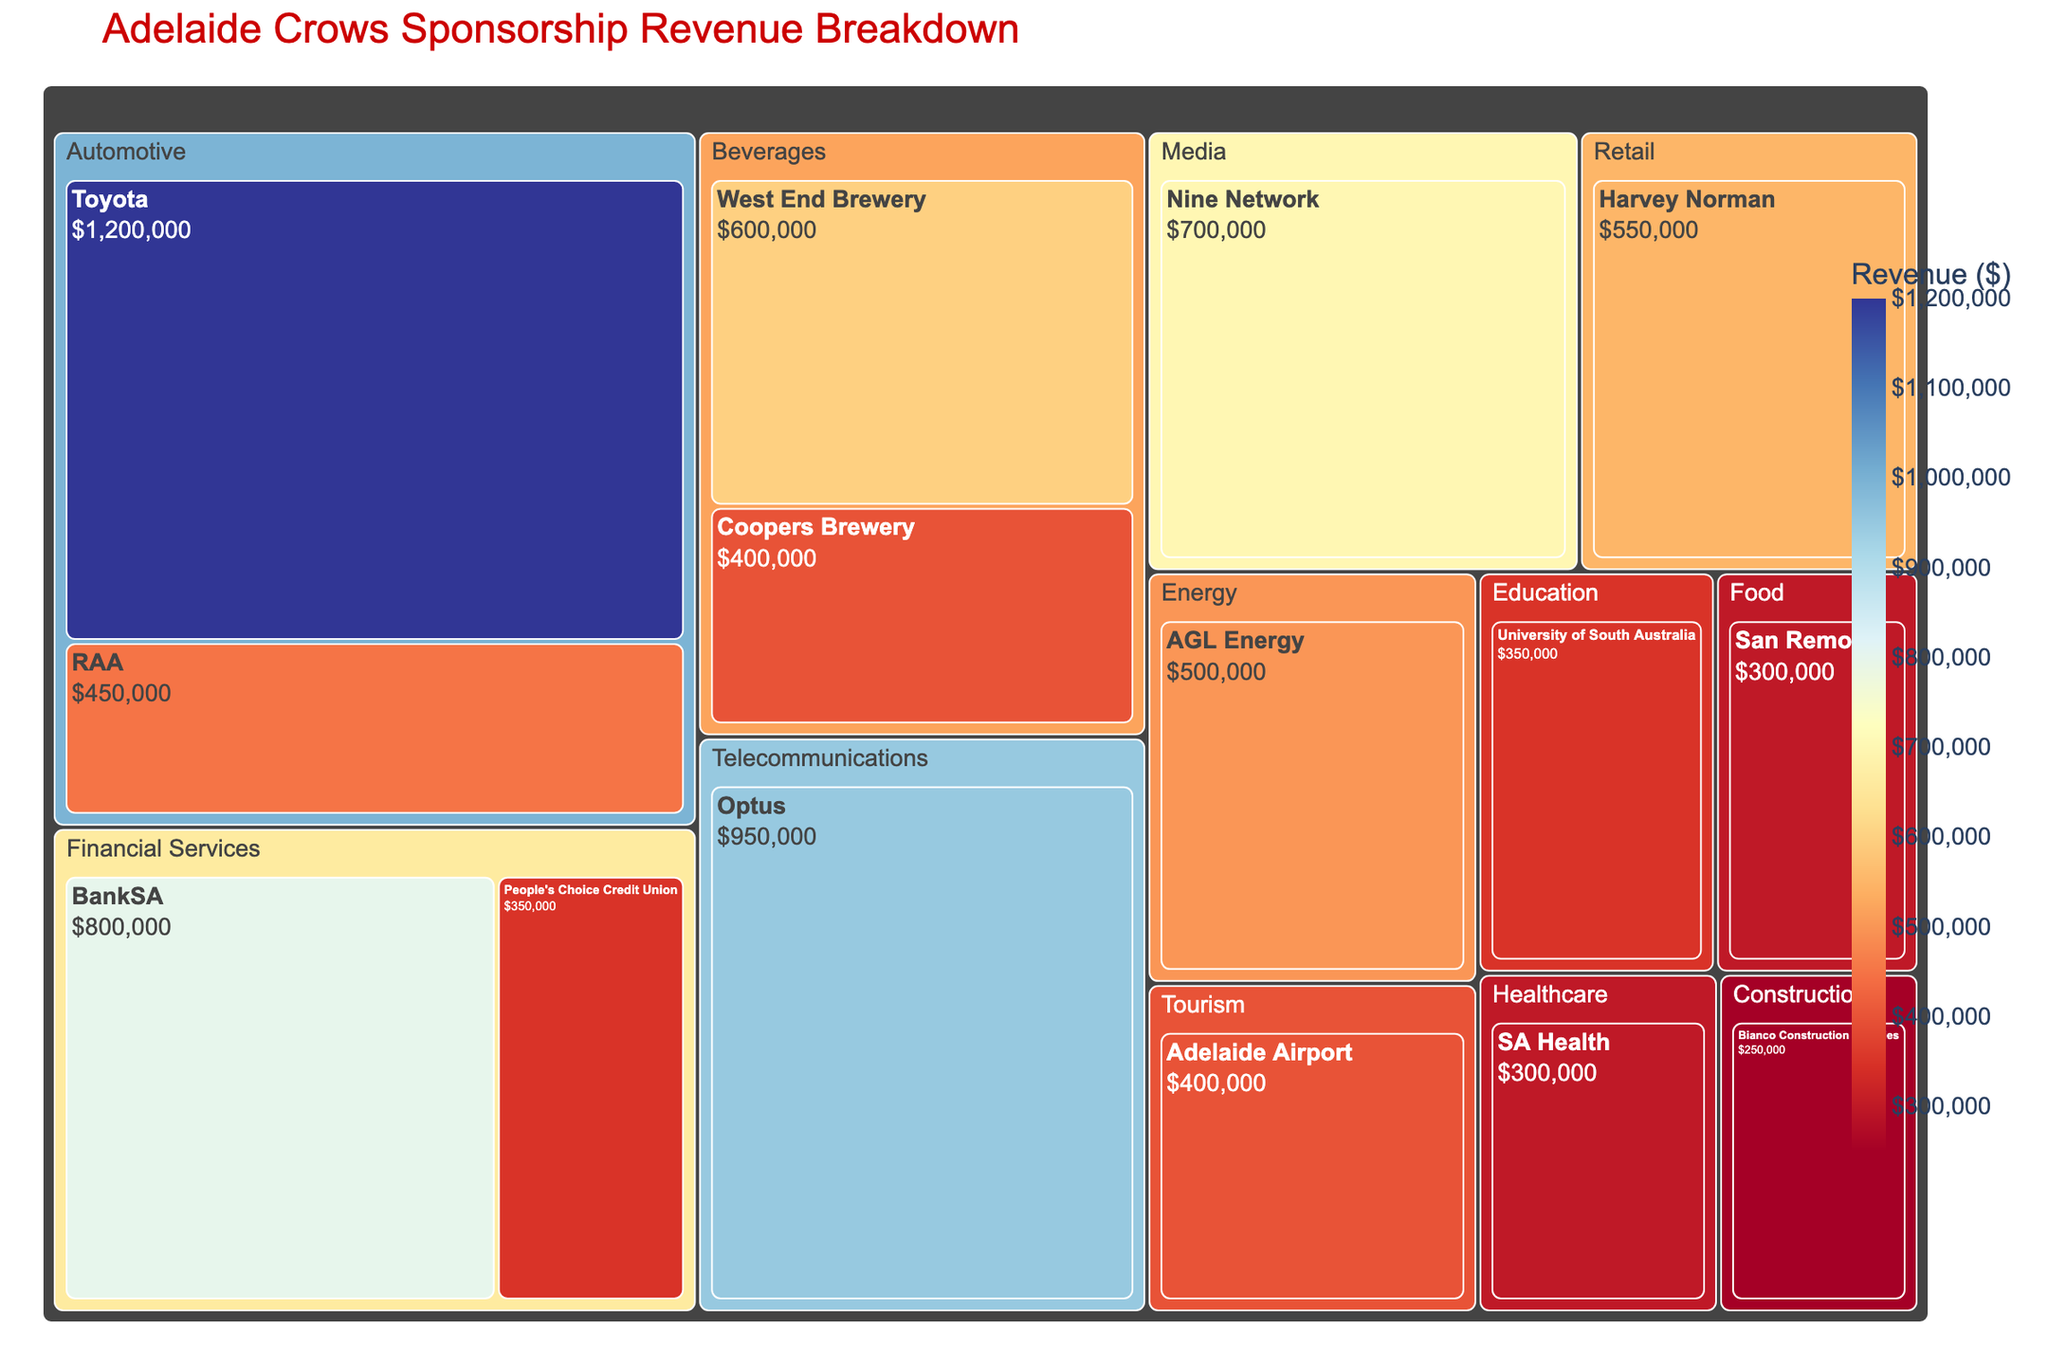What is the title of the treemap? The title is usually placed prominently at the top of the plot. From the given context, the title of the treemap can be inferred.
Answer: Adelaide Crows Sponsorship Revenue Breakdown Which industry sector contributes the highest revenue? Visual inspection of the treemap will show that the largest segment by revenue is likely automotive, given that Toyota and RAA contribute substantial amounts.
Answer: Automotive How much does Toyota contribute to the total sponsorship revenue? Locate Toyota within the automotive sector section of the treemap and read its revenue label.
Answer: $1,200,000 Which sponsors contribute to the healthcare sector? Identify the healthcare section on the treemap and list the sponsors within that section.
Answer: SA Health What is the combined revenue from both beverage sponsors? Identify the beverage sector and sum the revenues from West End Brewery and Coopers Brewery.
Answer: $1,000,000 How does the revenue from BankSA compare to that from Optus? Locate both BankSA and Optus on the treemap, compare their revenue values directly.
Answer: Optus has a higher revenue than BankSA Which industry contributes the least amount of sponsorship revenue? Locate the smallest segment on the treemap and note the industry labeled there.
Answer: Construction How many sponsors are contributing to the financial services sector? Count the number of sponsors listed within the financial services sector on the treemap.
Answer: 2 Calculate the total revenue for the telecommunications sector. Locate the telecommunications sector and read its total revenue label.
Answer: $950,000 In terms of total revenue, how does the education sector compare to the tourism sector? Find and compare the total revenue labels for the education and tourism sectors on the treemap.
Answer: Tourism sector revenue is equal to that of the education sector 